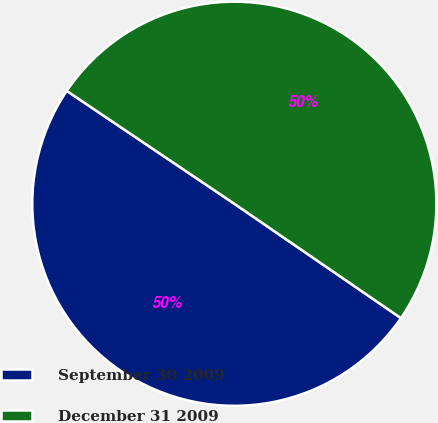Convert chart. <chart><loc_0><loc_0><loc_500><loc_500><pie_chart><fcel>September 30 2009<fcel>December 31 2009<nl><fcel>49.86%<fcel>50.14%<nl></chart> 